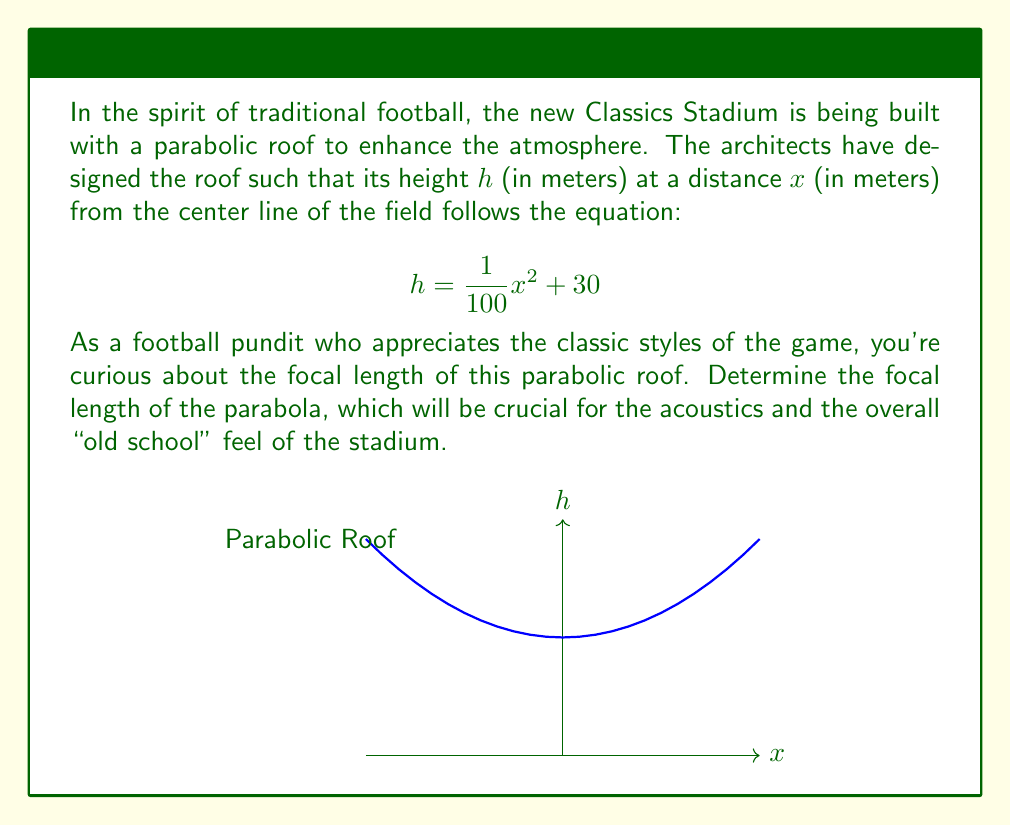Could you help me with this problem? Let's approach this step-by-step:

1) The general equation of a parabola with vertex $(0,k)$ and axis of symmetry parallel to the y-axis is:

   $$h = a(x-h)^2 + k$$

   where $a$ is related to the focal length.

2) Our equation is in the form:

   $$h = \frac{1}{100}x^2 + 30$$

3) Comparing this to the general form, we can see that:
   - $a = \frac{1}{100}$
   - $k = 30$ (the vertex is at $(0,30)$)

4) The focal length of a parabola is given by the formula:

   $$f = \frac{1}{4a}$$

5) Substituting our value of $a$:

   $$f = \frac{1}{4(\frac{1}{100})} = \frac{100}{4} = 25$$

Therefore, the focal length of the parabolic roof is 25 meters.

This focal length will create a "sweet spot" for sound reflection, reminiscent of the atmospheric old stadiums where chants and cheers would resonate perfectly, enhancing the traditional football experience.
Answer: 25 meters 